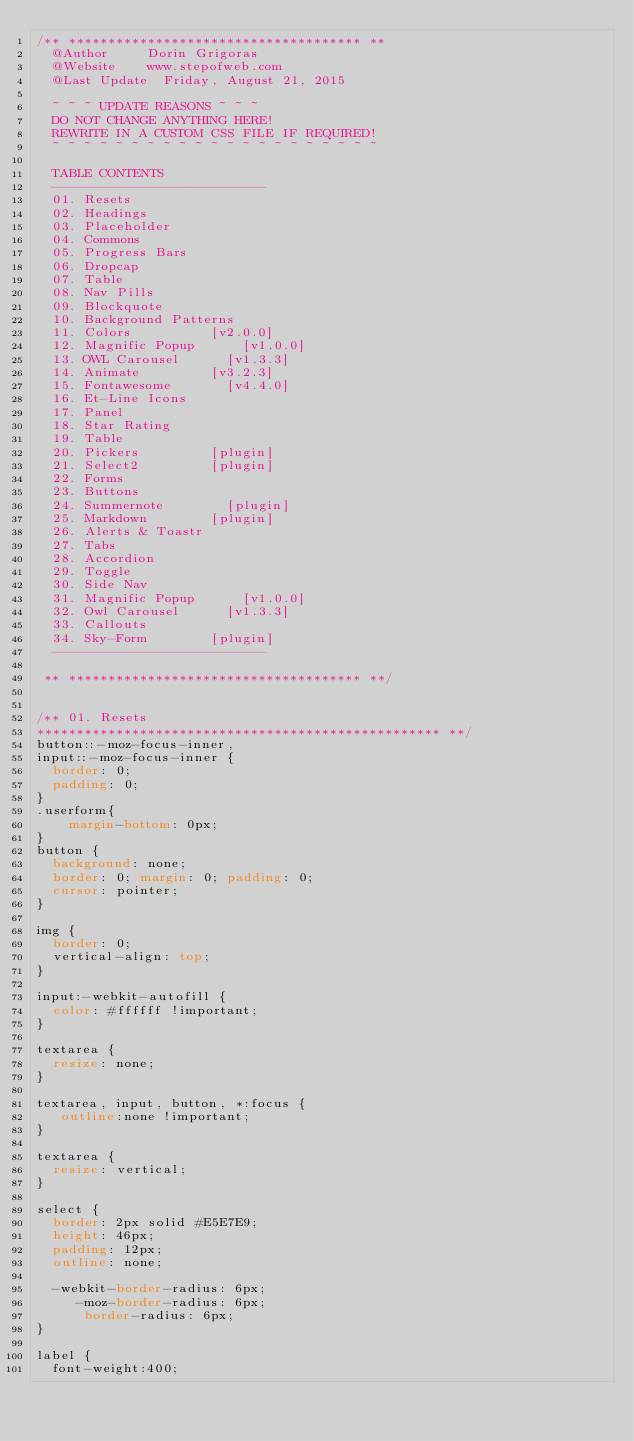<code> <loc_0><loc_0><loc_500><loc_500><_CSS_>/** ************************************* **
	@Author			Dorin Grigoras
	@Website		www.stepofweb.com
	@Last Update	Friday, August 21, 2015

	~ ~ ~ UPDATE REASONS ~ ~ ~
	DO NOT CHANGE ANYTHING HERE!
	REWRITE IN A CUSTOM CSS FILE IF REQUIRED!
	~ ~ ~ ~ ~ ~ ~ ~ ~ ~ ~ ~ ~ ~ ~ ~ ~ ~ ~ ~ ~

	TABLE CONTENTS
	---------------------------
	01. Resets
	02. Headings
	03. Placeholder
	04. Commons
	05. Progress Bars
	06. Dropcap
	07. Table
	08. Nav Pills
	09. Blockquote
	10. Background Patterns
	11. Colors					[v2.0.0]
	12. Magnific Popup			[v1.0.0]
	13. OWL Carousel 			[v1.3.3]
	14. Animate					[v3.2.3]
	15. Fontawesome 			[v4.4.0]
	16. Et-Line Icons
	17. Panel
	18. Star Rating
	19. Table
	20. Pickers					[plugin]
	21. Select2					[plugin]
	22. Forms
	23. Buttons
	24. Summernote				[plugin]
	25. Markdown				[plugin]
	26. Alerts & Toastr
	27. Tabs
	28. Accordion
	29. Toggle
	30. Side Nav
	31. Magnific Popup 			[v1.0.0]
	32. Owl Carousel 			[v1.3.3]
	33. Callouts
	34. Sky-Form				[plugin]
	---------------------------

 ** ************************************* **/
 
 
/**	01. Resets
*************************************************** **/
button::-moz-focus-inner, 
input::-moz-focus-inner {
	border: 0;
	padding: 0;
}
.userform{
    margin-bottom: 0px;
}
button {
	background: none;
	border: 0; margin: 0; padding: 0;
	cursor: pointer;
}

img {
	border: 0;
	vertical-align: top;
}

input:-webkit-autofill {
	color: #ffffff !important;
}

textarea {
	resize: none;
}

textarea, input, button, *:focus {
	 outline:none !important;
}

textarea {
	resize: vertical;
}

select {
	border: 2px solid #E5E7E9;
	height: 46px;
	padding: 12px;
	outline: none;

	-webkit-border-radius: 6px;
	   -moz-border-radius: 6px;
			border-radius: 6px;
}

label {
	font-weight:400;</code> 